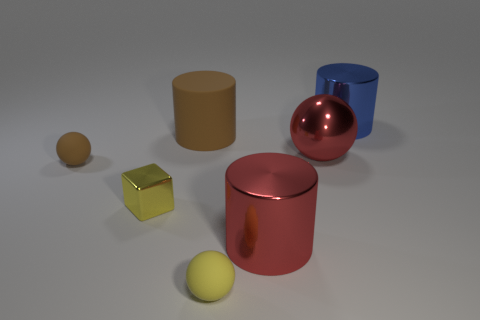Add 3 tiny shiny objects. How many objects exist? 10 Subtract all blocks. How many objects are left? 6 Subtract 1 red balls. How many objects are left? 6 Subtract all large matte objects. Subtract all brown things. How many objects are left? 4 Add 7 blue things. How many blue things are left? 8 Add 2 brown cylinders. How many brown cylinders exist? 3 